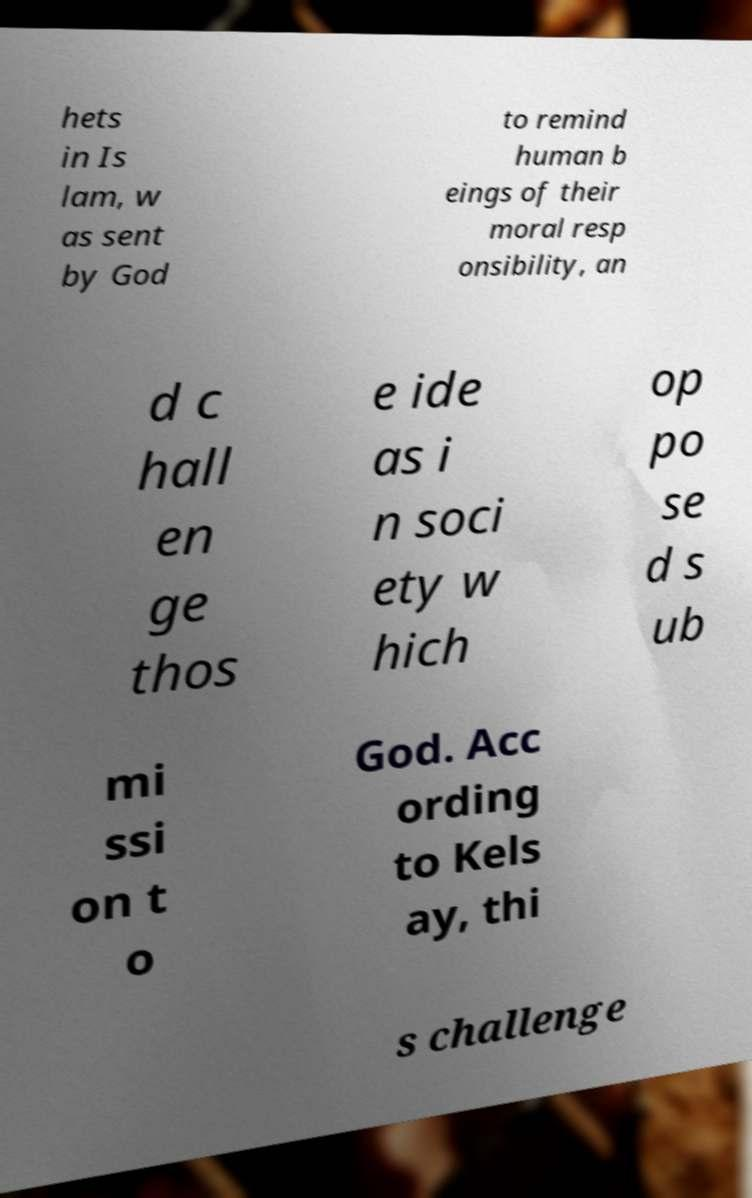Can you accurately transcribe the text from the provided image for me? hets in Is lam, w as sent by God to remind human b eings of their moral resp onsibility, an d c hall en ge thos e ide as i n soci ety w hich op po se d s ub mi ssi on t o God. Acc ording to Kels ay, thi s challenge 